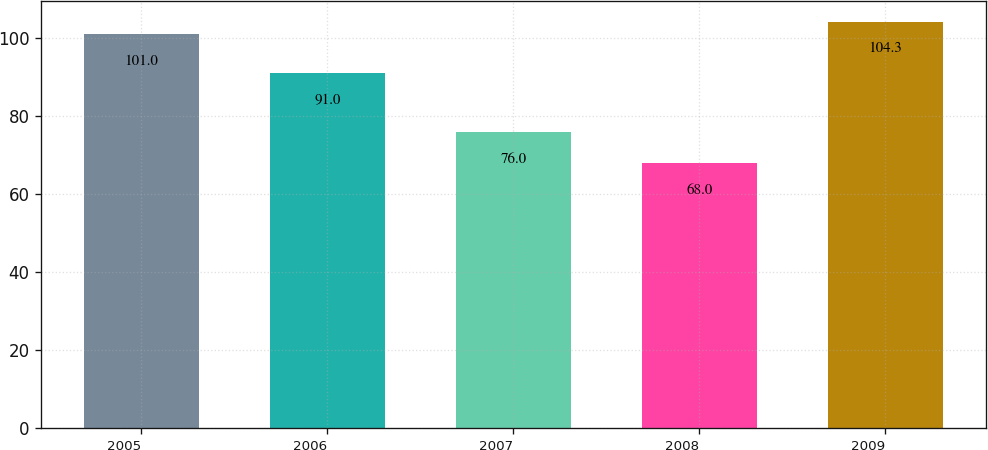<chart> <loc_0><loc_0><loc_500><loc_500><bar_chart><fcel>2005<fcel>2006<fcel>2007<fcel>2008<fcel>2009<nl><fcel>101<fcel>91<fcel>76<fcel>68<fcel>104.3<nl></chart> 